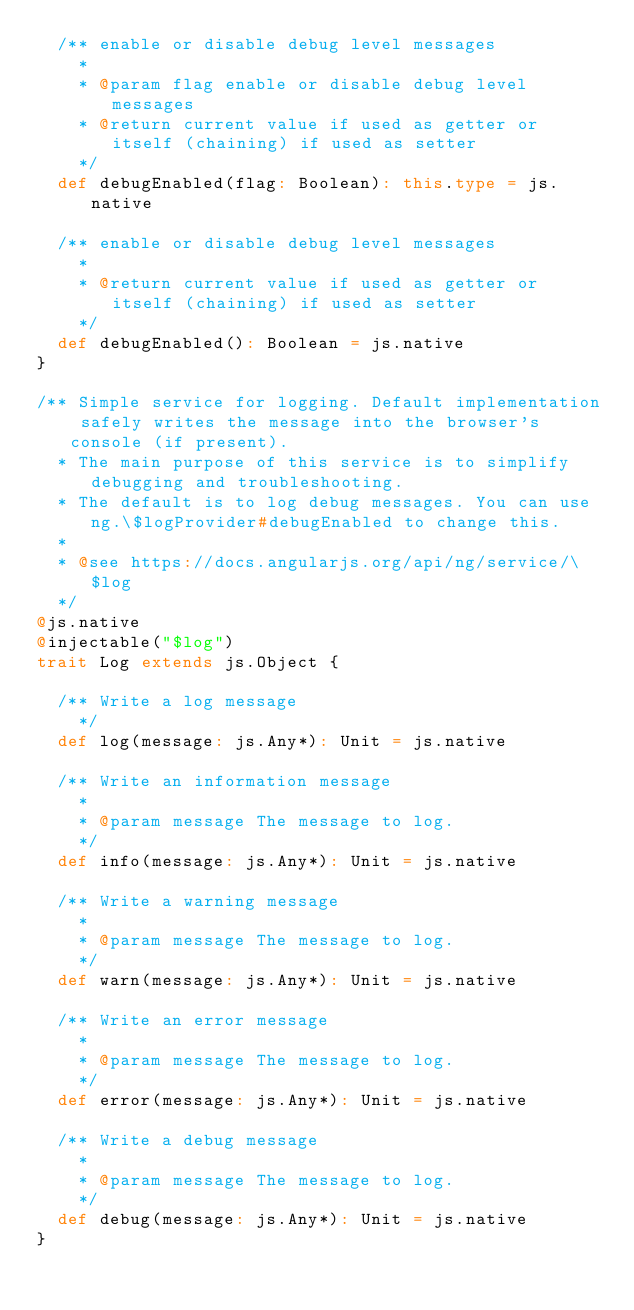Convert code to text. <code><loc_0><loc_0><loc_500><loc_500><_Scala_>  /** enable or disable debug level messages
    *
    * @param flag enable or disable debug level messages
    * @return current value if used as getter or itself (chaining) if used as setter
    */
  def debugEnabled(flag: Boolean): this.type = js.native

  /** enable or disable debug level messages
    *
    * @return current value if used as getter or itself (chaining) if used as setter
    */
  def debugEnabled(): Boolean = js.native
}

/** Simple service for logging. Default implementation safely writes the message into the browser's console (if present).
  * The main purpose of this service is to simplify debugging and troubleshooting.
  * The default is to log debug messages. You can use ng.\$logProvider#debugEnabled to change this.
  *
  * @see https://docs.angularjs.org/api/ng/service/\$log
  */
@js.native
@injectable("$log")
trait Log extends js.Object {

  /** Write a log message
    */
  def log(message: js.Any*): Unit = js.native

  /** Write an information message
    *
    * @param message The message to log.
    */
  def info(message: js.Any*): Unit = js.native

  /** Write a warning message
    *
    * @param message The message to log.
    */
  def warn(message: js.Any*): Unit = js.native

  /** Write an error message
    *
    * @param message The message to log.
    */
  def error(message: js.Any*): Unit = js.native

  /** Write a debug message
    *
    * @param message The message to log.
    */
  def debug(message: js.Any*): Unit = js.native
}
</code> 